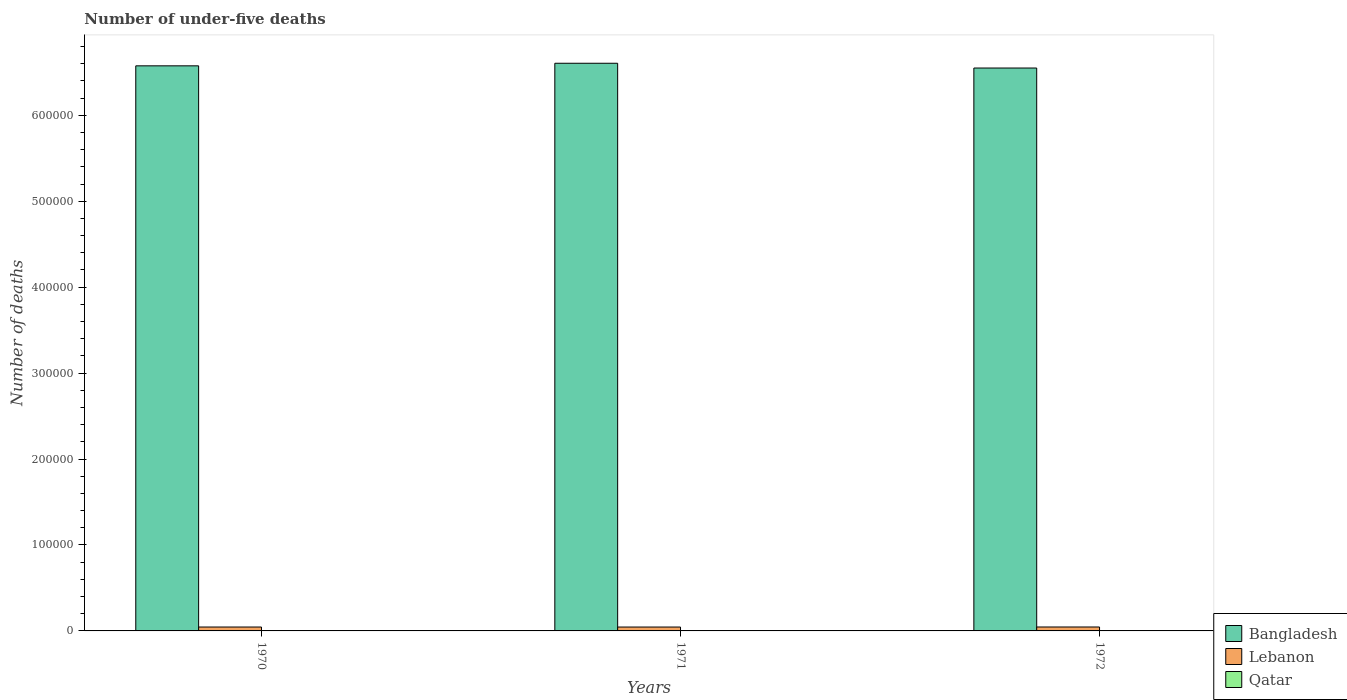Are the number of bars per tick equal to the number of legend labels?
Offer a very short reply. Yes. How many bars are there on the 2nd tick from the right?
Ensure brevity in your answer.  3. In how many cases, is the number of bars for a given year not equal to the number of legend labels?
Ensure brevity in your answer.  0. What is the number of under-five deaths in Lebanon in 1972?
Give a very brief answer. 4564. Across all years, what is the maximum number of under-five deaths in Bangladesh?
Keep it short and to the point. 6.61e+05. Across all years, what is the minimum number of under-five deaths in Qatar?
Offer a terse response. 246. In which year was the number of under-five deaths in Bangladesh minimum?
Your answer should be very brief. 1972. What is the total number of under-five deaths in Qatar in the graph?
Provide a short and direct response. 749. What is the difference between the number of under-five deaths in Lebanon in 1971 and that in 1972?
Offer a very short reply. -40. What is the difference between the number of under-five deaths in Qatar in 1970 and the number of under-five deaths in Lebanon in 1971?
Make the answer very short. -4270. What is the average number of under-five deaths in Qatar per year?
Your answer should be very brief. 249.67. In the year 1971, what is the difference between the number of under-five deaths in Qatar and number of under-five deaths in Bangladesh?
Give a very brief answer. -6.60e+05. What is the ratio of the number of under-five deaths in Qatar in 1971 to that in 1972?
Provide a succinct answer. 1.01. What is the difference between the highest and the lowest number of under-five deaths in Bangladesh?
Provide a short and direct response. 5541. Is the sum of the number of under-five deaths in Lebanon in 1970 and 1971 greater than the maximum number of under-five deaths in Qatar across all years?
Make the answer very short. Yes. What does the 3rd bar from the left in 1972 represents?
Provide a succinct answer. Qatar. Is it the case that in every year, the sum of the number of under-five deaths in Qatar and number of under-five deaths in Lebanon is greater than the number of under-five deaths in Bangladesh?
Your response must be concise. No. Are all the bars in the graph horizontal?
Offer a very short reply. No. Are the values on the major ticks of Y-axis written in scientific E-notation?
Provide a succinct answer. No. Does the graph contain grids?
Offer a terse response. No. How many legend labels are there?
Keep it short and to the point. 3. How are the legend labels stacked?
Offer a very short reply. Vertical. What is the title of the graph?
Offer a terse response. Number of under-five deaths. Does "St. Kitts and Nevis" appear as one of the legend labels in the graph?
Provide a succinct answer. No. What is the label or title of the Y-axis?
Keep it short and to the point. Number of deaths. What is the Number of deaths of Bangladesh in 1970?
Provide a short and direct response. 6.58e+05. What is the Number of deaths in Lebanon in 1970?
Provide a short and direct response. 4544. What is the Number of deaths of Qatar in 1970?
Keep it short and to the point. 254. What is the Number of deaths in Bangladesh in 1971?
Provide a succinct answer. 6.61e+05. What is the Number of deaths of Lebanon in 1971?
Ensure brevity in your answer.  4524. What is the Number of deaths in Qatar in 1971?
Your response must be concise. 249. What is the Number of deaths of Bangladesh in 1972?
Give a very brief answer. 6.55e+05. What is the Number of deaths of Lebanon in 1972?
Give a very brief answer. 4564. What is the Number of deaths in Qatar in 1972?
Make the answer very short. 246. Across all years, what is the maximum Number of deaths in Bangladesh?
Offer a very short reply. 6.61e+05. Across all years, what is the maximum Number of deaths in Lebanon?
Your response must be concise. 4564. Across all years, what is the maximum Number of deaths of Qatar?
Offer a terse response. 254. Across all years, what is the minimum Number of deaths in Bangladesh?
Give a very brief answer. 6.55e+05. Across all years, what is the minimum Number of deaths of Lebanon?
Ensure brevity in your answer.  4524. Across all years, what is the minimum Number of deaths of Qatar?
Ensure brevity in your answer.  246. What is the total Number of deaths in Bangladesh in the graph?
Provide a short and direct response. 1.97e+06. What is the total Number of deaths of Lebanon in the graph?
Offer a terse response. 1.36e+04. What is the total Number of deaths in Qatar in the graph?
Make the answer very short. 749. What is the difference between the Number of deaths in Bangladesh in 1970 and that in 1971?
Provide a succinct answer. -2991. What is the difference between the Number of deaths in Bangladesh in 1970 and that in 1972?
Give a very brief answer. 2550. What is the difference between the Number of deaths of Lebanon in 1970 and that in 1972?
Provide a succinct answer. -20. What is the difference between the Number of deaths in Qatar in 1970 and that in 1972?
Your response must be concise. 8. What is the difference between the Number of deaths of Bangladesh in 1971 and that in 1972?
Offer a very short reply. 5541. What is the difference between the Number of deaths of Bangladesh in 1970 and the Number of deaths of Lebanon in 1971?
Your answer should be compact. 6.53e+05. What is the difference between the Number of deaths in Bangladesh in 1970 and the Number of deaths in Qatar in 1971?
Your answer should be compact. 6.57e+05. What is the difference between the Number of deaths in Lebanon in 1970 and the Number of deaths in Qatar in 1971?
Provide a succinct answer. 4295. What is the difference between the Number of deaths of Bangladesh in 1970 and the Number of deaths of Lebanon in 1972?
Your answer should be compact. 6.53e+05. What is the difference between the Number of deaths in Bangladesh in 1970 and the Number of deaths in Qatar in 1972?
Offer a terse response. 6.57e+05. What is the difference between the Number of deaths in Lebanon in 1970 and the Number of deaths in Qatar in 1972?
Your response must be concise. 4298. What is the difference between the Number of deaths of Bangladesh in 1971 and the Number of deaths of Lebanon in 1972?
Give a very brief answer. 6.56e+05. What is the difference between the Number of deaths of Bangladesh in 1971 and the Number of deaths of Qatar in 1972?
Offer a terse response. 6.60e+05. What is the difference between the Number of deaths in Lebanon in 1971 and the Number of deaths in Qatar in 1972?
Offer a very short reply. 4278. What is the average Number of deaths of Bangladesh per year?
Make the answer very short. 6.58e+05. What is the average Number of deaths of Lebanon per year?
Your answer should be very brief. 4544. What is the average Number of deaths of Qatar per year?
Offer a very short reply. 249.67. In the year 1970, what is the difference between the Number of deaths of Bangladesh and Number of deaths of Lebanon?
Offer a terse response. 6.53e+05. In the year 1970, what is the difference between the Number of deaths of Bangladesh and Number of deaths of Qatar?
Your answer should be compact. 6.57e+05. In the year 1970, what is the difference between the Number of deaths in Lebanon and Number of deaths in Qatar?
Provide a succinct answer. 4290. In the year 1971, what is the difference between the Number of deaths of Bangladesh and Number of deaths of Lebanon?
Your response must be concise. 6.56e+05. In the year 1971, what is the difference between the Number of deaths in Bangladesh and Number of deaths in Qatar?
Provide a succinct answer. 6.60e+05. In the year 1971, what is the difference between the Number of deaths in Lebanon and Number of deaths in Qatar?
Offer a terse response. 4275. In the year 1972, what is the difference between the Number of deaths in Bangladesh and Number of deaths in Lebanon?
Offer a terse response. 6.50e+05. In the year 1972, what is the difference between the Number of deaths in Bangladesh and Number of deaths in Qatar?
Ensure brevity in your answer.  6.55e+05. In the year 1972, what is the difference between the Number of deaths in Lebanon and Number of deaths in Qatar?
Your response must be concise. 4318. What is the ratio of the Number of deaths of Bangladesh in 1970 to that in 1971?
Your response must be concise. 1. What is the ratio of the Number of deaths of Lebanon in 1970 to that in 1971?
Provide a succinct answer. 1. What is the ratio of the Number of deaths of Qatar in 1970 to that in 1971?
Offer a very short reply. 1.02. What is the ratio of the Number of deaths of Bangladesh in 1970 to that in 1972?
Ensure brevity in your answer.  1. What is the ratio of the Number of deaths in Lebanon in 1970 to that in 1972?
Offer a terse response. 1. What is the ratio of the Number of deaths of Qatar in 1970 to that in 1972?
Offer a terse response. 1.03. What is the ratio of the Number of deaths of Bangladesh in 1971 to that in 1972?
Make the answer very short. 1.01. What is the ratio of the Number of deaths in Lebanon in 1971 to that in 1972?
Ensure brevity in your answer.  0.99. What is the ratio of the Number of deaths in Qatar in 1971 to that in 1972?
Your answer should be compact. 1.01. What is the difference between the highest and the second highest Number of deaths in Bangladesh?
Offer a terse response. 2991. What is the difference between the highest and the second highest Number of deaths in Qatar?
Provide a short and direct response. 5. What is the difference between the highest and the lowest Number of deaths of Bangladesh?
Provide a succinct answer. 5541. What is the difference between the highest and the lowest Number of deaths in Lebanon?
Your answer should be very brief. 40. 